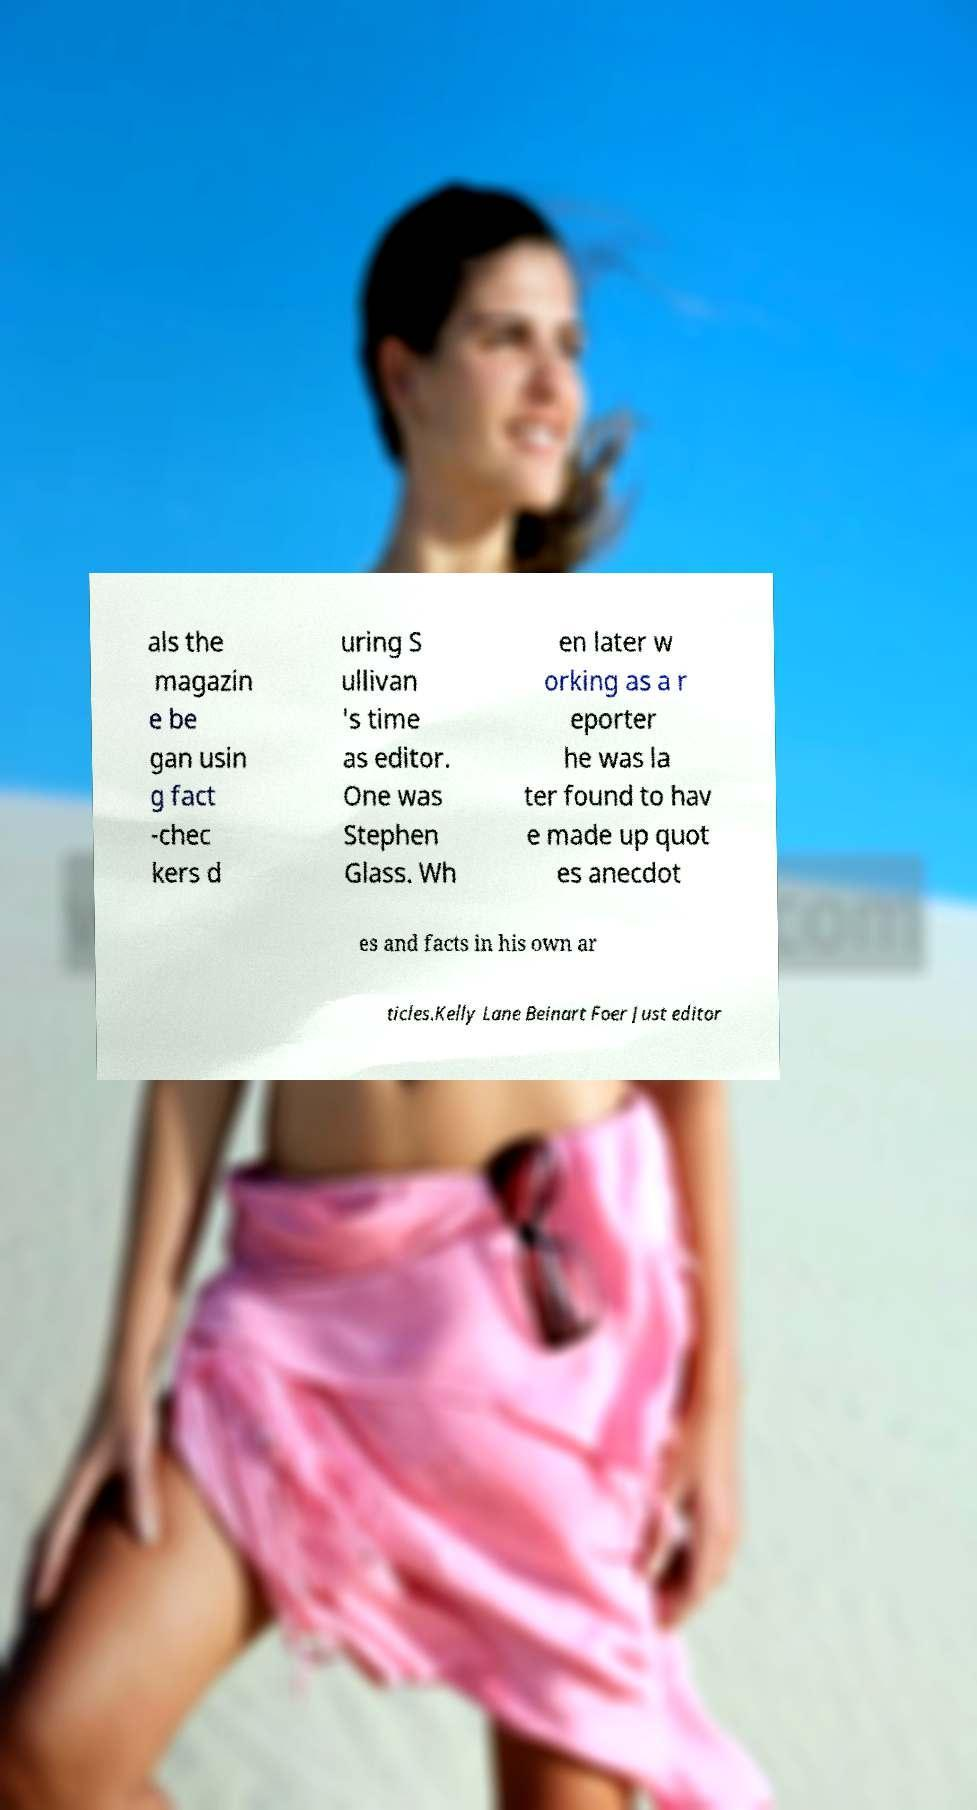I need the written content from this picture converted into text. Can you do that? als the magazin e be gan usin g fact -chec kers d uring S ullivan 's time as editor. One was Stephen Glass. Wh en later w orking as a r eporter he was la ter found to hav e made up quot es anecdot es and facts in his own ar ticles.Kelly Lane Beinart Foer Just editor 